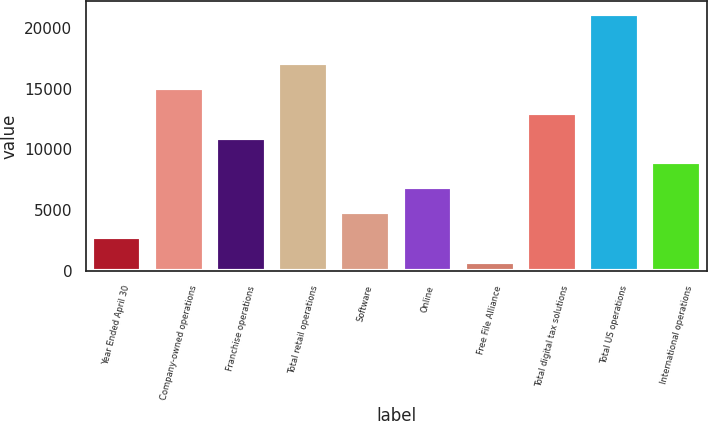Convert chart to OTSL. <chart><loc_0><loc_0><loc_500><loc_500><bar_chart><fcel>Year Ended April 30<fcel>Company-owned operations<fcel>Franchise operations<fcel>Total retail operations<fcel>Software<fcel>Online<fcel>Free File Alliance<fcel>Total digital tax solutions<fcel>Total US operations<fcel>International operations<nl><fcel>2824<fcel>15040<fcel>10968<fcel>17076<fcel>4860<fcel>6896<fcel>788<fcel>13004<fcel>21148<fcel>8932<nl></chart> 